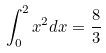<formula> <loc_0><loc_0><loc_500><loc_500>\int _ { 0 } ^ { 2 } x ^ { 2 } d x = \frac { 8 } { 3 }</formula> 